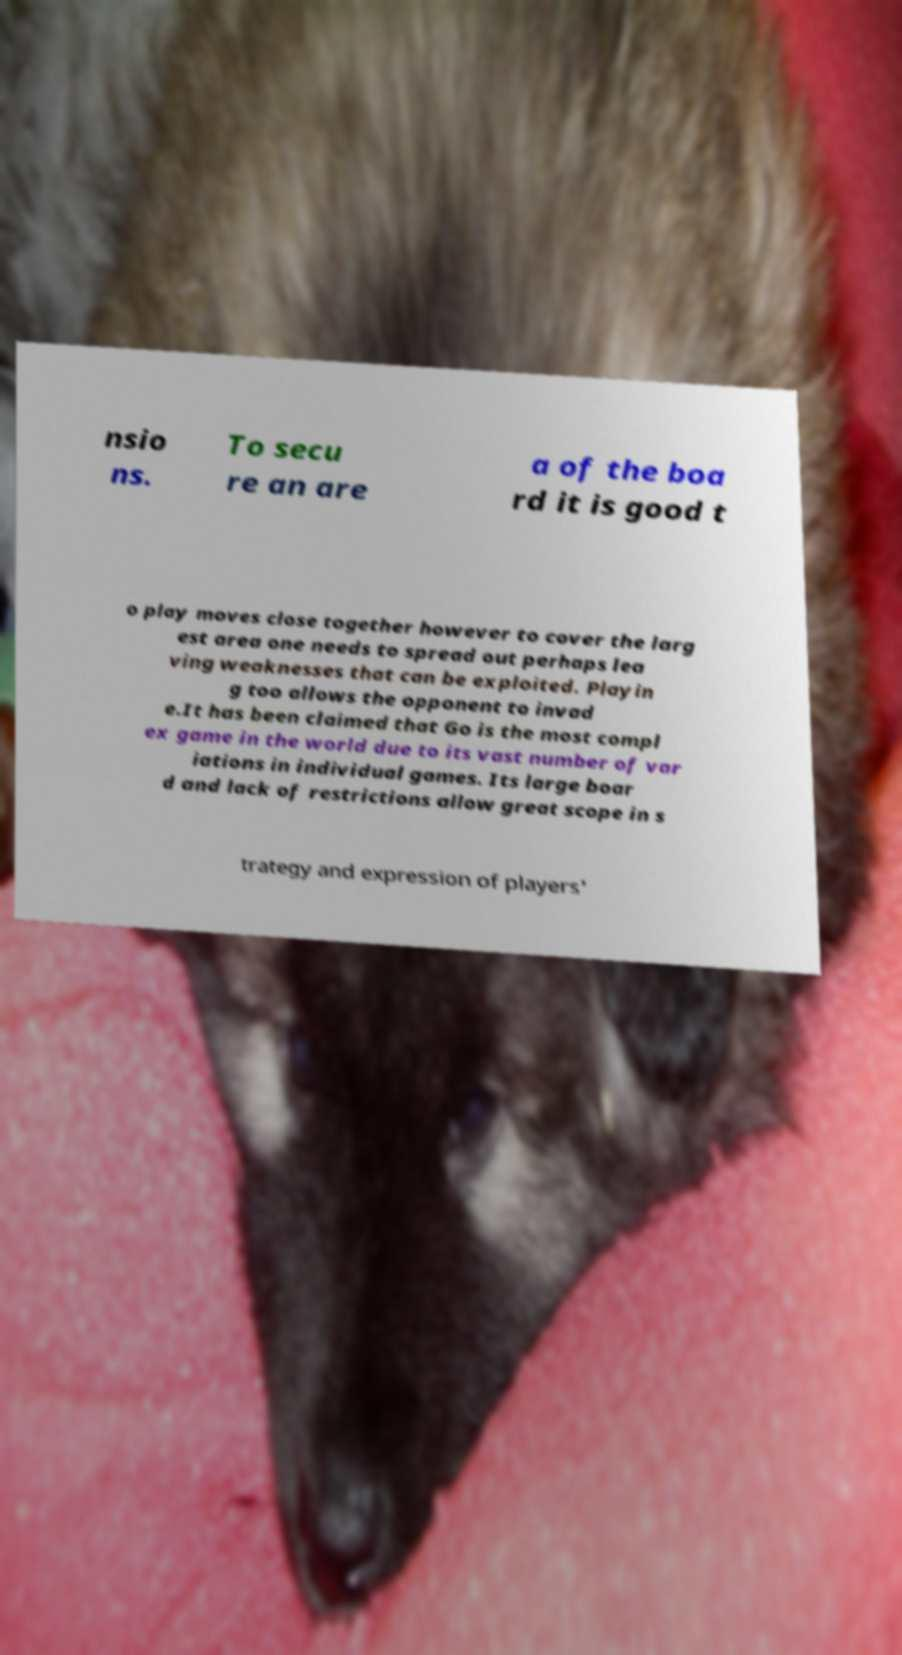Please read and relay the text visible in this image. What does it say? nsio ns. To secu re an are a of the boa rd it is good t o play moves close together however to cover the larg est area one needs to spread out perhaps lea ving weaknesses that can be exploited. Playin g too allows the opponent to invad e.It has been claimed that Go is the most compl ex game in the world due to its vast number of var iations in individual games. Its large boar d and lack of restrictions allow great scope in s trategy and expression of players' 